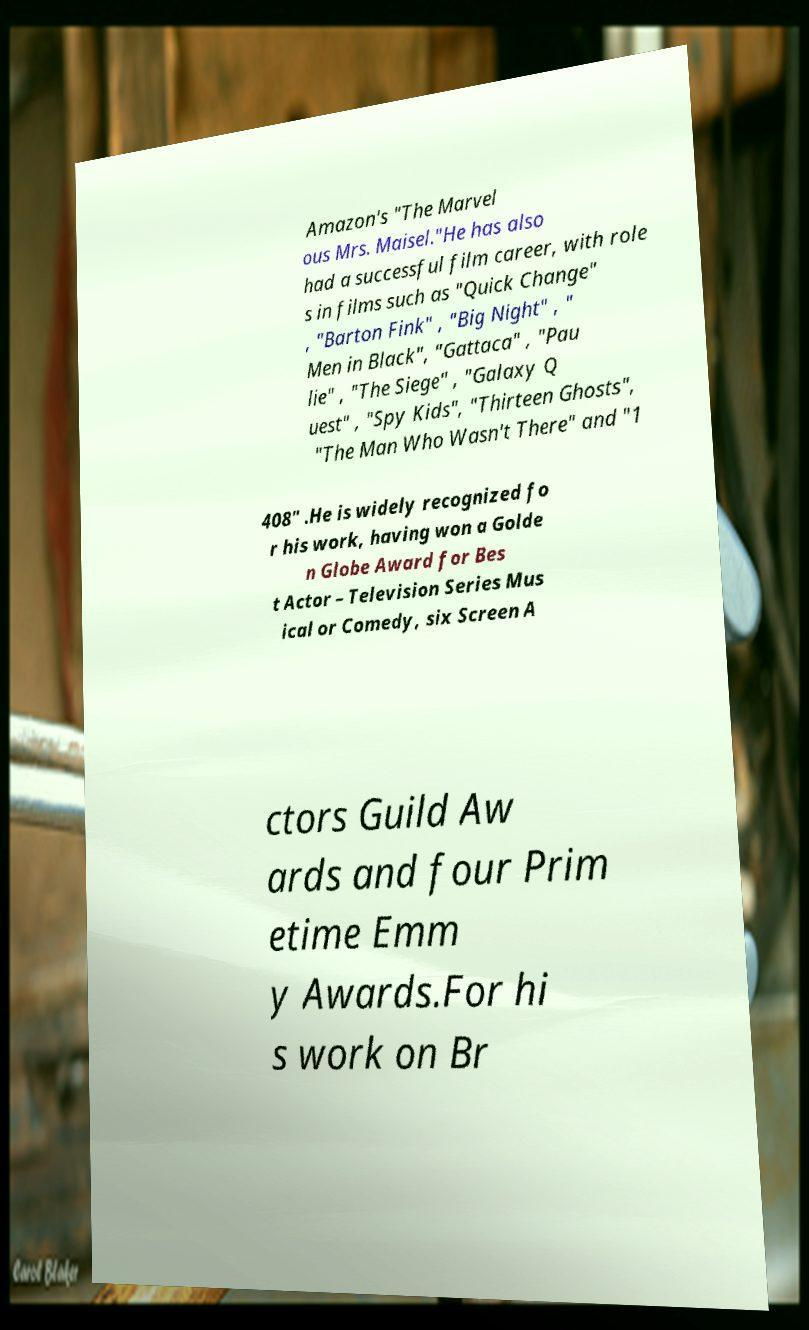I need the written content from this picture converted into text. Can you do that? Amazon's "The Marvel ous Mrs. Maisel."He has also had a successful film career, with role s in films such as "Quick Change" , "Barton Fink" , "Big Night" , " Men in Black", "Gattaca" , "Pau lie" , "The Siege" , "Galaxy Q uest" , "Spy Kids", "Thirteen Ghosts", "The Man Who Wasn't There" and "1 408" .He is widely recognized fo r his work, having won a Golde n Globe Award for Bes t Actor – Television Series Mus ical or Comedy, six Screen A ctors Guild Aw ards and four Prim etime Emm y Awards.For hi s work on Br 